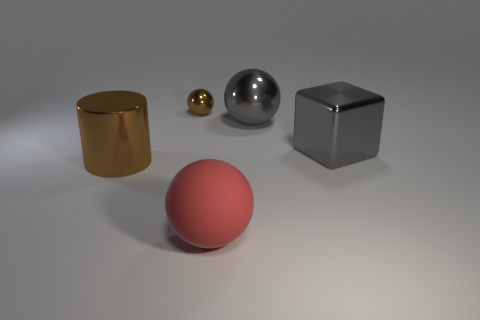How many metal things are big gray cubes or small brown objects?
Make the answer very short. 2. Is there anything else that is the same material as the large block?
Give a very brief answer. Yes. What is the size of the metal ball that is on the right side of the large ball in front of the gray object behind the large metal cube?
Keep it short and to the point. Large. There is a metallic object that is to the right of the small brown shiny ball and to the left of the large block; what size is it?
Give a very brief answer. Large. There is a big metallic object behind the large gray cube; is its color the same as the large metal cube that is in front of the tiny object?
Provide a succinct answer. Yes. There is a brown metallic sphere; what number of large objects are right of it?
Make the answer very short. 3. Is there a sphere on the left side of the large ball to the left of the large gray metal thing behind the large shiny cube?
Offer a very short reply. Yes. What number of other gray shiny balls are the same size as the gray ball?
Offer a terse response. 0. What material is the large gray thing to the left of the gray metallic object to the right of the gray ball?
Make the answer very short. Metal. There is a large metallic object that is on the left side of the brown metallic thing behind the large metal thing left of the big rubber sphere; what is its shape?
Keep it short and to the point. Cylinder. 